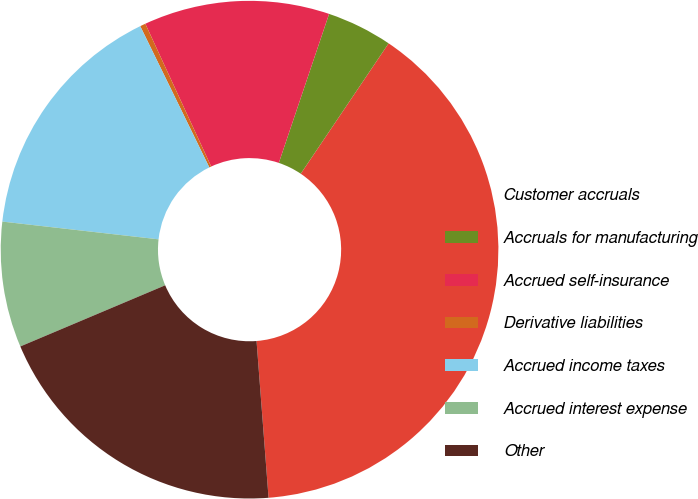Convert chart. <chart><loc_0><loc_0><loc_500><loc_500><pie_chart><fcel>Customer accruals<fcel>Accruals for manufacturing<fcel>Accrued self-insurance<fcel>Derivative liabilities<fcel>Accrued income taxes<fcel>Accrued interest expense<fcel>Other<nl><fcel>39.35%<fcel>4.26%<fcel>12.06%<fcel>0.36%<fcel>15.96%<fcel>8.16%<fcel>19.86%<nl></chart> 